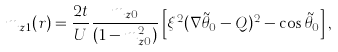<formula> <loc_0><loc_0><loc_500><loc_500>m _ { z 1 } ( { r } ) = \frac { 2 t } { U } \frac { m _ { z 0 } } { ( 1 - m _ { z 0 } ^ { 2 } ) } \left [ \xi ^ { 2 } ( \nabla \tilde { \theta } _ { 0 } - { Q } ) ^ { 2 } - \cos \tilde { \theta } _ { 0 } \right ] ,</formula> 